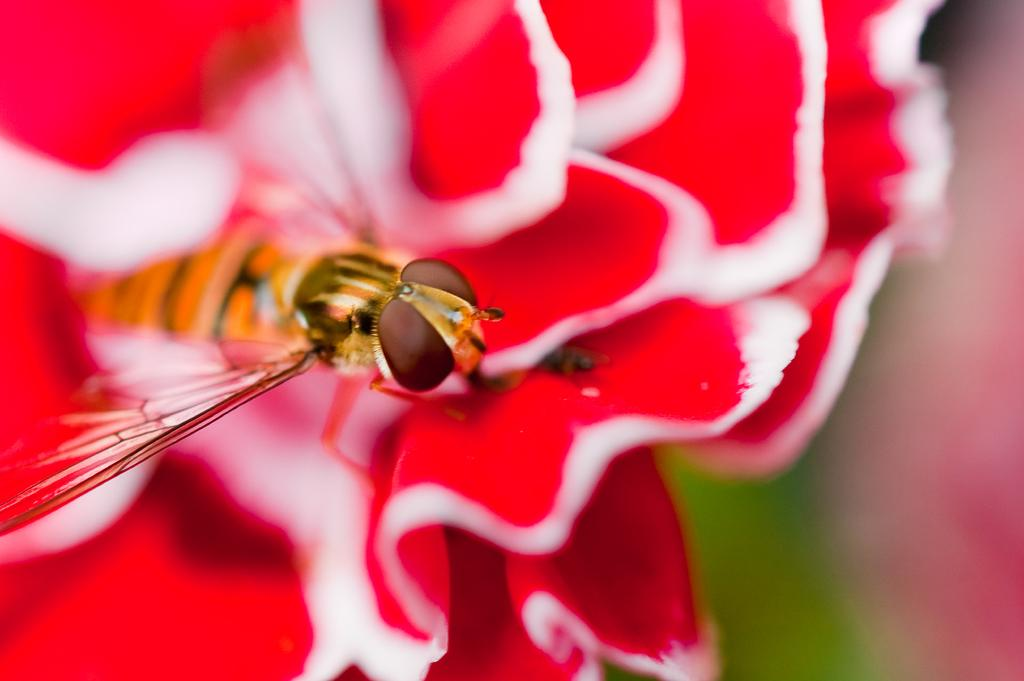What is the main subject in the center of the image? There is a flower in the center of the image. What colors can be seen on the flower? The flower has red and white colors. Is there anything else present on the flower? Yes, there is an insect on the flower. What colors can be seen on the insect? The insect has yellow and black colors. Can you hear the flower blowing in the wind in the image? There is no sound or indication of wind in the image, so it cannot be determined if the flower is blowing. 